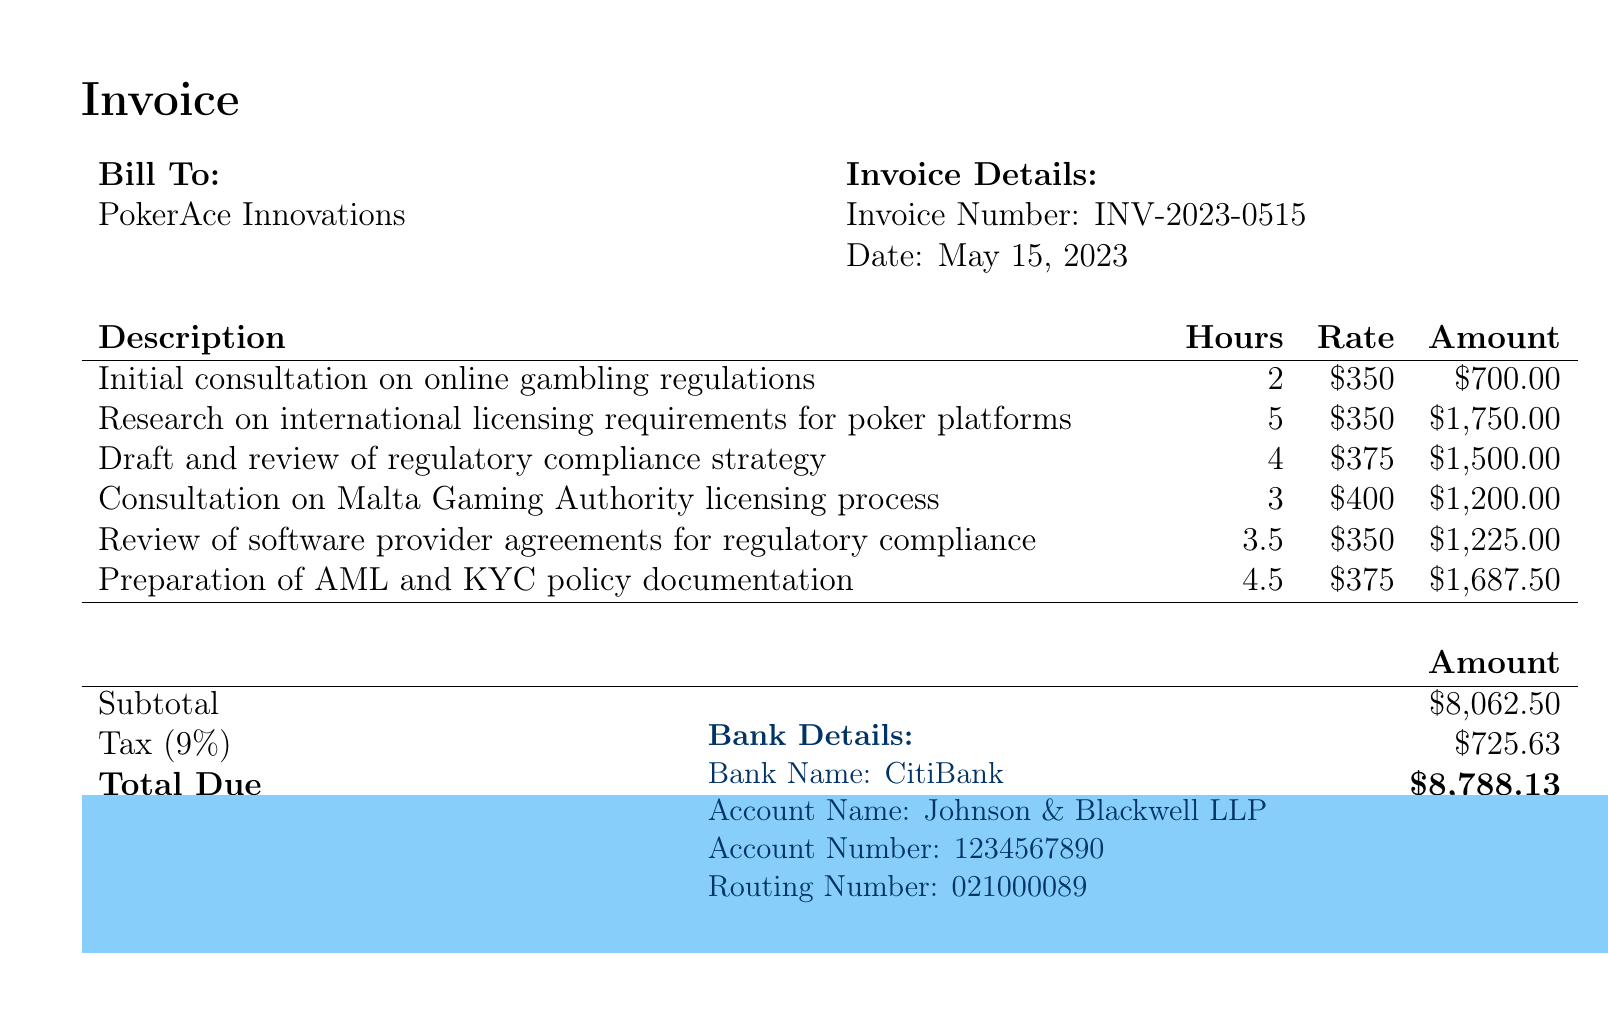What is the invoice number? The invoice number is listed under the Invoice Details section of the document.
Answer: INV-2023-0515 What is the total due amount? The total due amount is shown at the bottom of the invoice summary.
Answer: $8,788.13 How many hours were spent on the research of international licensing requirements? The hours for this task are indicated in the table detailing services rendered.
Answer: 5 What is the rate charged for the consultation on Malta Gaming Authority licensing process? The rate is specified in the Description table alongside the corresponding service.
Answer: $400 What percentage of tax was applied to the subtotal? The tax rate is mentioned in the summary section of the invoice.
Answer: 9% How many services were billed in total? The total number of services can be counted from the descriptions listed in the bill.
Answer: 6 What is the name of the firm that issued the bill? The firm's name is found prominently at the top of the invoice.
Answer: Johnson & Blackwell LLP What is the account name for the bank details? The account name is provided in the bank details section at the bottom of the invoice.
Answer: Johnson & Blackwell LLP What is the due date for payment? The payment terms specify the timeframe for payment within the document.
Answer: 30 days 